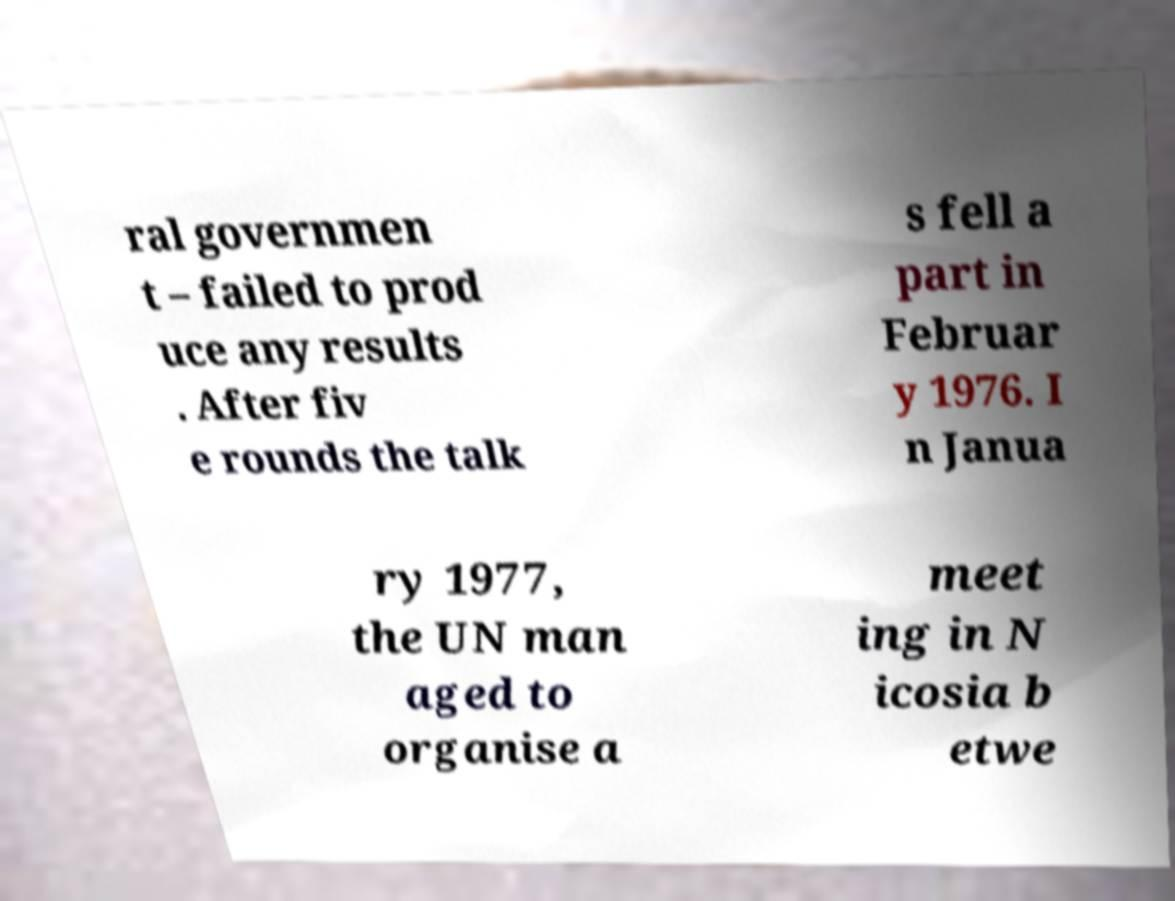What messages or text are displayed in this image? I need them in a readable, typed format. ral governmen t – failed to prod uce any results . After fiv e rounds the talk s fell a part in Februar y 1976. I n Janua ry 1977, the UN man aged to organise a meet ing in N icosia b etwe 